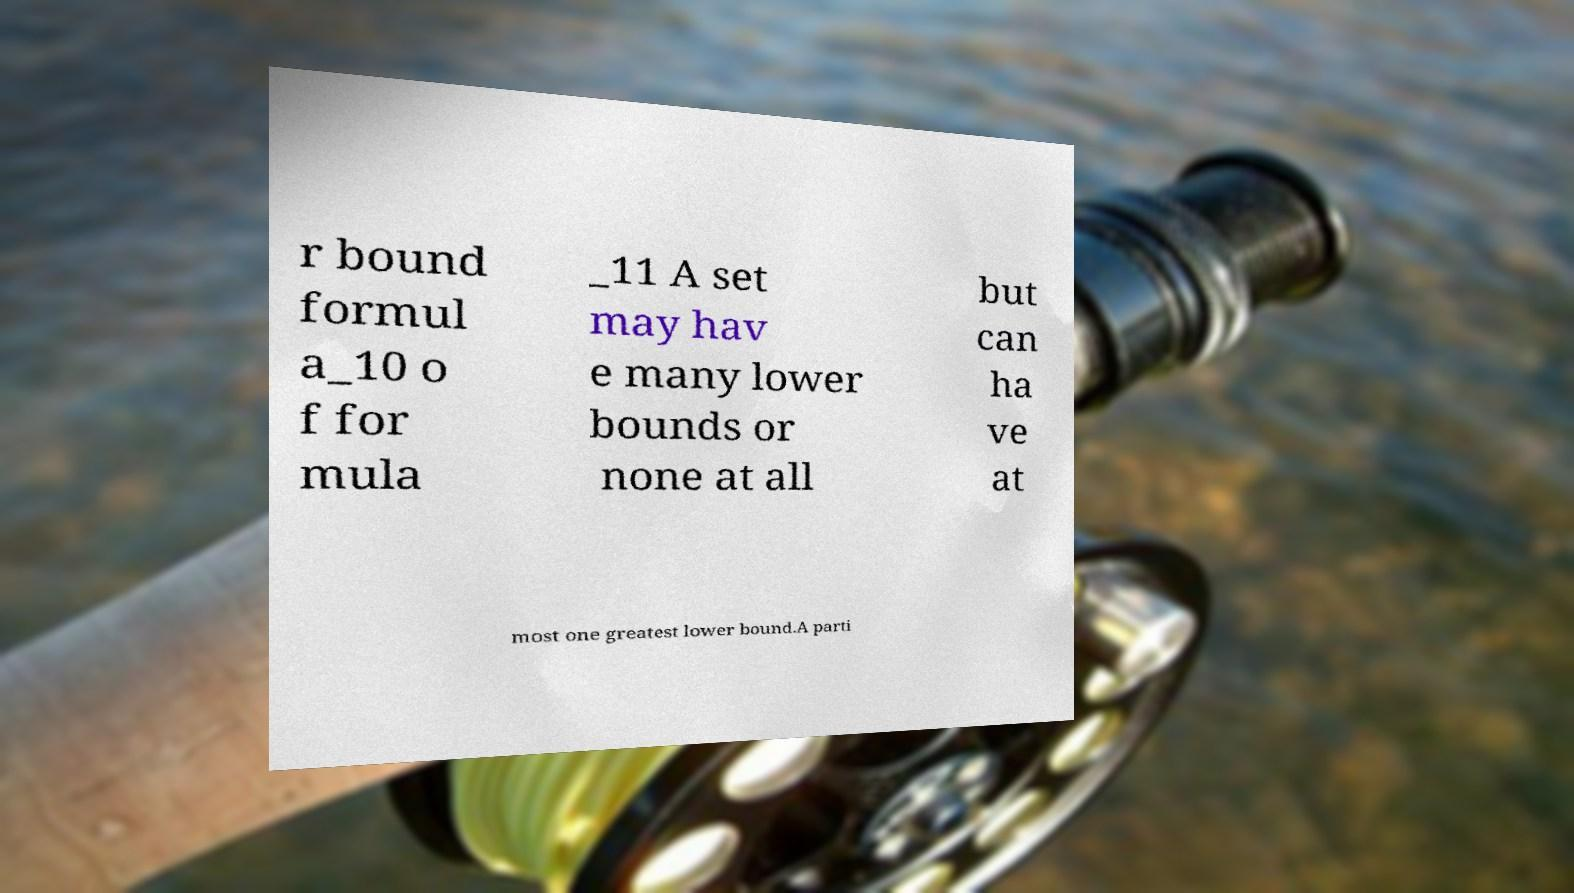For documentation purposes, I need the text within this image transcribed. Could you provide that? r bound formul a_10 o f for mula _11 A set may hav e many lower bounds or none at all but can ha ve at most one greatest lower bound.A parti 